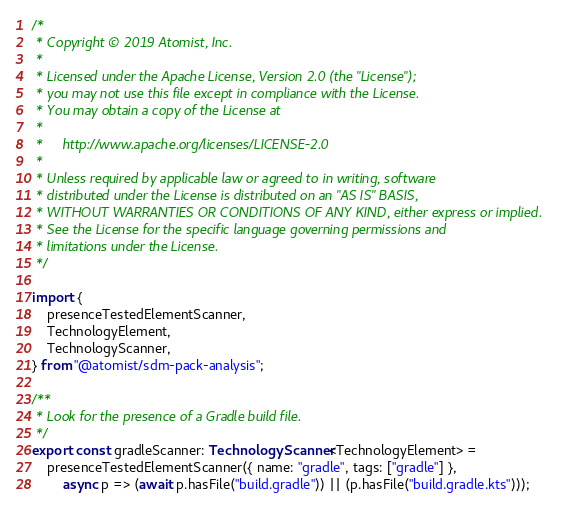<code> <loc_0><loc_0><loc_500><loc_500><_TypeScript_>/*
 * Copyright © 2019 Atomist, Inc.
 *
 * Licensed under the Apache License, Version 2.0 (the "License");
 * you may not use this file except in compliance with the License.
 * You may obtain a copy of the License at
 *
 *     http://www.apache.org/licenses/LICENSE-2.0
 *
 * Unless required by applicable law or agreed to in writing, software
 * distributed under the License is distributed on an "AS IS" BASIS,
 * WITHOUT WARRANTIES OR CONDITIONS OF ANY KIND, either express or implied.
 * See the License for the specific language governing permissions and
 * limitations under the License.
 */

import {
    presenceTestedElementScanner,
    TechnologyElement,
    TechnologyScanner,
} from "@atomist/sdm-pack-analysis";

/**
 * Look for the presence of a Gradle build file.
 */
export const gradleScanner: TechnologyScanner<TechnologyElement> =
    presenceTestedElementScanner({ name: "gradle", tags: ["gradle"] },
        async p => (await p.hasFile("build.gradle")) || (p.hasFile("build.gradle.kts")));
</code> 